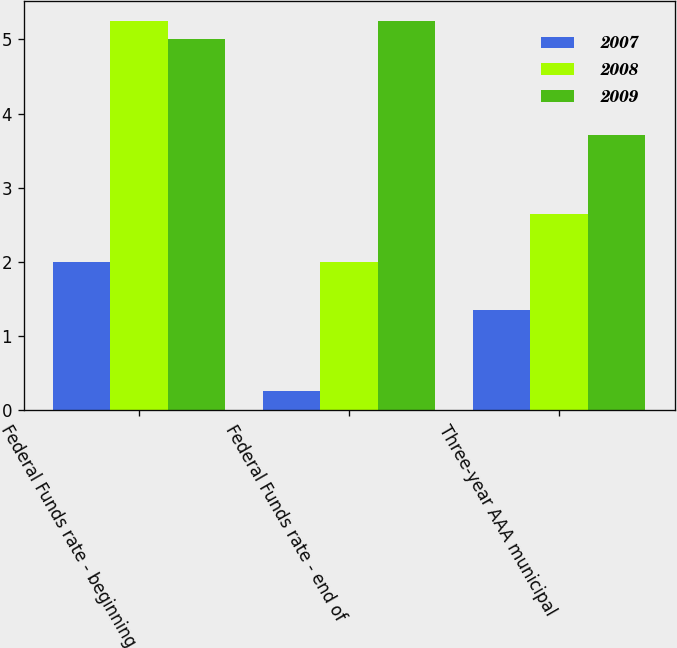<chart> <loc_0><loc_0><loc_500><loc_500><stacked_bar_chart><ecel><fcel>Federal Funds rate - beginning<fcel>Federal Funds rate - end of<fcel>Three-year AAA municipal<nl><fcel>2007<fcel>2<fcel>0.25<fcel>1.35<nl><fcel>2008<fcel>5.25<fcel>2<fcel>2.65<nl><fcel>2009<fcel>5<fcel>5.25<fcel>3.71<nl></chart> 